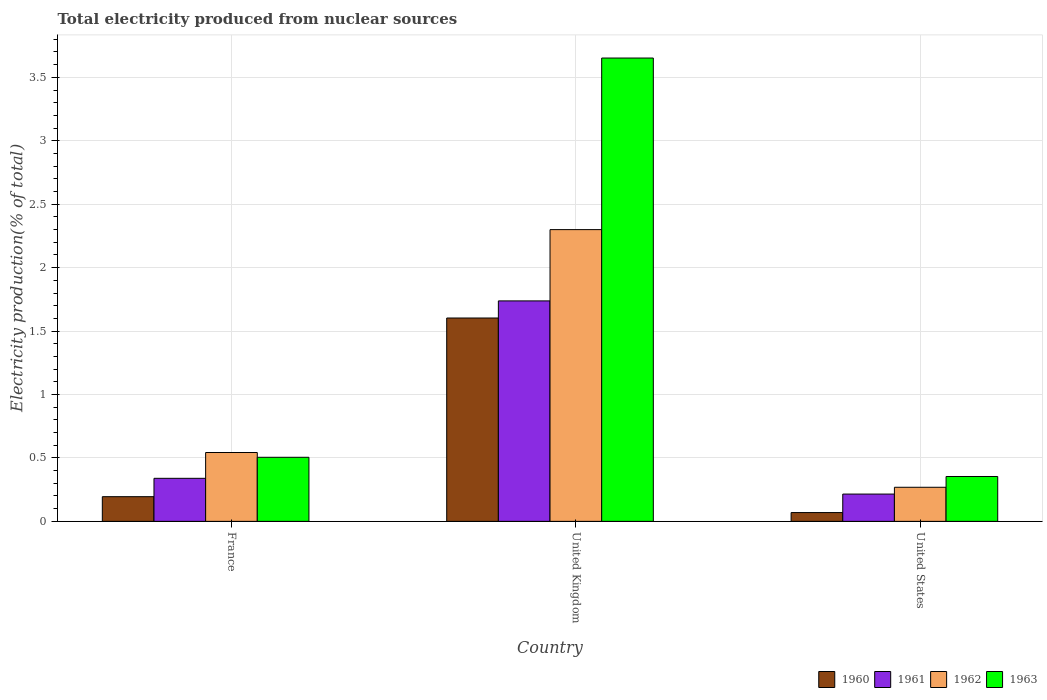Are the number of bars on each tick of the X-axis equal?
Your response must be concise. Yes. What is the label of the 2nd group of bars from the left?
Your answer should be very brief. United Kingdom. In how many cases, is the number of bars for a given country not equal to the number of legend labels?
Provide a succinct answer. 0. What is the total electricity produced in 1960 in United Kingdom?
Your answer should be very brief. 1.6. Across all countries, what is the maximum total electricity produced in 1960?
Provide a short and direct response. 1.6. Across all countries, what is the minimum total electricity produced in 1961?
Offer a terse response. 0.22. In which country was the total electricity produced in 1962 maximum?
Offer a terse response. United Kingdom. What is the total total electricity produced in 1961 in the graph?
Your answer should be compact. 2.29. What is the difference between the total electricity produced in 1960 in France and that in United States?
Provide a succinct answer. 0.13. What is the difference between the total electricity produced in 1962 in United States and the total electricity produced in 1960 in United Kingdom?
Offer a terse response. -1.33. What is the average total electricity produced in 1963 per country?
Offer a terse response. 1.5. What is the difference between the total electricity produced of/in 1962 and total electricity produced of/in 1961 in France?
Your answer should be very brief. 0.2. What is the ratio of the total electricity produced in 1961 in France to that in United Kingdom?
Ensure brevity in your answer.  0.2. Is the difference between the total electricity produced in 1962 in France and United States greater than the difference between the total electricity produced in 1961 in France and United States?
Make the answer very short. Yes. What is the difference between the highest and the second highest total electricity produced in 1962?
Keep it short and to the point. 0.27. What is the difference between the highest and the lowest total electricity produced in 1961?
Keep it short and to the point. 1.52. In how many countries, is the total electricity produced in 1963 greater than the average total electricity produced in 1963 taken over all countries?
Keep it short and to the point. 1. Is it the case that in every country, the sum of the total electricity produced in 1961 and total electricity produced in 1962 is greater than the sum of total electricity produced in 1963 and total electricity produced in 1960?
Make the answer very short. No. What does the 4th bar from the left in France represents?
Ensure brevity in your answer.  1963. Is it the case that in every country, the sum of the total electricity produced in 1961 and total electricity produced in 1962 is greater than the total electricity produced in 1960?
Keep it short and to the point. Yes. How many bars are there?
Your answer should be very brief. 12. How many countries are there in the graph?
Your answer should be very brief. 3. Are the values on the major ticks of Y-axis written in scientific E-notation?
Ensure brevity in your answer.  No. Does the graph contain any zero values?
Your response must be concise. No. How many legend labels are there?
Keep it short and to the point. 4. What is the title of the graph?
Keep it short and to the point. Total electricity produced from nuclear sources. Does "1974" appear as one of the legend labels in the graph?
Provide a succinct answer. No. What is the label or title of the X-axis?
Offer a very short reply. Country. What is the Electricity production(% of total) of 1960 in France?
Give a very brief answer. 0.19. What is the Electricity production(% of total) of 1961 in France?
Ensure brevity in your answer.  0.34. What is the Electricity production(% of total) of 1962 in France?
Your response must be concise. 0.54. What is the Electricity production(% of total) of 1963 in France?
Offer a very short reply. 0.51. What is the Electricity production(% of total) of 1960 in United Kingdom?
Your response must be concise. 1.6. What is the Electricity production(% of total) in 1961 in United Kingdom?
Offer a very short reply. 1.74. What is the Electricity production(% of total) in 1962 in United Kingdom?
Offer a very short reply. 2.3. What is the Electricity production(% of total) of 1963 in United Kingdom?
Your response must be concise. 3.65. What is the Electricity production(% of total) of 1960 in United States?
Keep it short and to the point. 0.07. What is the Electricity production(% of total) of 1961 in United States?
Offer a very short reply. 0.22. What is the Electricity production(% of total) in 1962 in United States?
Your answer should be very brief. 0.27. What is the Electricity production(% of total) in 1963 in United States?
Ensure brevity in your answer.  0.35. Across all countries, what is the maximum Electricity production(% of total) of 1960?
Give a very brief answer. 1.6. Across all countries, what is the maximum Electricity production(% of total) of 1961?
Keep it short and to the point. 1.74. Across all countries, what is the maximum Electricity production(% of total) in 1962?
Make the answer very short. 2.3. Across all countries, what is the maximum Electricity production(% of total) in 1963?
Ensure brevity in your answer.  3.65. Across all countries, what is the minimum Electricity production(% of total) of 1960?
Give a very brief answer. 0.07. Across all countries, what is the minimum Electricity production(% of total) of 1961?
Give a very brief answer. 0.22. Across all countries, what is the minimum Electricity production(% of total) of 1962?
Your answer should be compact. 0.27. Across all countries, what is the minimum Electricity production(% of total) in 1963?
Make the answer very short. 0.35. What is the total Electricity production(% of total) of 1960 in the graph?
Your response must be concise. 1.87. What is the total Electricity production(% of total) in 1961 in the graph?
Your response must be concise. 2.29. What is the total Electricity production(% of total) of 1962 in the graph?
Provide a succinct answer. 3.11. What is the total Electricity production(% of total) in 1963 in the graph?
Provide a succinct answer. 4.51. What is the difference between the Electricity production(% of total) in 1960 in France and that in United Kingdom?
Provide a succinct answer. -1.41. What is the difference between the Electricity production(% of total) in 1961 in France and that in United Kingdom?
Provide a short and direct response. -1.4. What is the difference between the Electricity production(% of total) of 1962 in France and that in United Kingdom?
Give a very brief answer. -1.76. What is the difference between the Electricity production(% of total) of 1963 in France and that in United Kingdom?
Your answer should be compact. -3.15. What is the difference between the Electricity production(% of total) in 1960 in France and that in United States?
Make the answer very short. 0.13. What is the difference between the Electricity production(% of total) in 1961 in France and that in United States?
Keep it short and to the point. 0.12. What is the difference between the Electricity production(% of total) in 1962 in France and that in United States?
Give a very brief answer. 0.27. What is the difference between the Electricity production(% of total) in 1963 in France and that in United States?
Make the answer very short. 0.15. What is the difference between the Electricity production(% of total) of 1960 in United Kingdom and that in United States?
Provide a succinct answer. 1.53. What is the difference between the Electricity production(% of total) of 1961 in United Kingdom and that in United States?
Provide a short and direct response. 1.52. What is the difference between the Electricity production(% of total) in 1962 in United Kingdom and that in United States?
Offer a terse response. 2.03. What is the difference between the Electricity production(% of total) of 1963 in United Kingdom and that in United States?
Offer a very short reply. 3.3. What is the difference between the Electricity production(% of total) of 1960 in France and the Electricity production(% of total) of 1961 in United Kingdom?
Make the answer very short. -1.54. What is the difference between the Electricity production(% of total) of 1960 in France and the Electricity production(% of total) of 1962 in United Kingdom?
Offer a very short reply. -2.11. What is the difference between the Electricity production(% of total) of 1960 in France and the Electricity production(% of total) of 1963 in United Kingdom?
Your answer should be very brief. -3.46. What is the difference between the Electricity production(% of total) in 1961 in France and the Electricity production(% of total) in 1962 in United Kingdom?
Ensure brevity in your answer.  -1.96. What is the difference between the Electricity production(% of total) in 1961 in France and the Electricity production(% of total) in 1963 in United Kingdom?
Make the answer very short. -3.31. What is the difference between the Electricity production(% of total) in 1962 in France and the Electricity production(% of total) in 1963 in United Kingdom?
Keep it short and to the point. -3.11. What is the difference between the Electricity production(% of total) of 1960 in France and the Electricity production(% of total) of 1961 in United States?
Make the answer very short. -0.02. What is the difference between the Electricity production(% of total) of 1960 in France and the Electricity production(% of total) of 1962 in United States?
Give a very brief answer. -0.07. What is the difference between the Electricity production(% of total) of 1960 in France and the Electricity production(% of total) of 1963 in United States?
Offer a very short reply. -0.16. What is the difference between the Electricity production(% of total) in 1961 in France and the Electricity production(% of total) in 1962 in United States?
Offer a terse response. 0.07. What is the difference between the Electricity production(% of total) in 1961 in France and the Electricity production(% of total) in 1963 in United States?
Ensure brevity in your answer.  -0.01. What is the difference between the Electricity production(% of total) in 1962 in France and the Electricity production(% of total) in 1963 in United States?
Keep it short and to the point. 0.19. What is the difference between the Electricity production(% of total) of 1960 in United Kingdom and the Electricity production(% of total) of 1961 in United States?
Make the answer very short. 1.39. What is the difference between the Electricity production(% of total) of 1960 in United Kingdom and the Electricity production(% of total) of 1962 in United States?
Make the answer very short. 1.33. What is the difference between the Electricity production(% of total) in 1960 in United Kingdom and the Electricity production(% of total) in 1963 in United States?
Offer a very short reply. 1.25. What is the difference between the Electricity production(% of total) of 1961 in United Kingdom and the Electricity production(% of total) of 1962 in United States?
Your answer should be very brief. 1.47. What is the difference between the Electricity production(% of total) of 1961 in United Kingdom and the Electricity production(% of total) of 1963 in United States?
Provide a succinct answer. 1.38. What is the difference between the Electricity production(% of total) in 1962 in United Kingdom and the Electricity production(% of total) in 1963 in United States?
Offer a terse response. 1.95. What is the average Electricity production(% of total) of 1960 per country?
Make the answer very short. 0.62. What is the average Electricity production(% of total) of 1961 per country?
Offer a terse response. 0.76. What is the average Electricity production(% of total) in 1962 per country?
Offer a terse response. 1.04. What is the average Electricity production(% of total) of 1963 per country?
Offer a very short reply. 1.5. What is the difference between the Electricity production(% of total) in 1960 and Electricity production(% of total) in 1961 in France?
Give a very brief answer. -0.14. What is the difference between the Electricity production(% of total) of 1960 and Electricity production(% of total) of 1962 in France?
Provide a short and direct response. -0.35. What is the difference between the Electricity production(% of total) of 1960 and Electricity production(% of total) of 1963 in France?
Make the answer very short. -0.31. What is the difference between the Electricity production(% of total) in 1961 and Electricity production(% of total) in 1962 in France?
Provide a short and direct response. -0.2. What is the difference between the Electricity production(% of total) in 1961 and Electricity production(% of total) in 1963 in France?
Your response must be concise. -0.17. What is the difference between the Electricity production(% of total) in 1962 and Electricity production(% of total) in 1963 in France?
Keep it short and to the point. 0.04. What is the difference between the Electricity production(% of total) in 1960 and Electricity production(% of total) in 1961 in United Kingdom?
Ensure brevity in your answer.  -0.13. What is the difference between the Electricity production(% of total) of 1960 and Electricity production(% of total) of 1962 in United Kingdom?
Offer a very short reply. -0.7. What is the difference between the Electricity production(% of total) of 1960 and Electricity production(% of total) of 1963 in United Kingdom?
Provide a short and direct response. -2.05. What is the difference between the Electricity production(% of total) in 1961 and Electricity production(% of total) in 1962 in United Kingdom?
Your response must be concise. -0.56. What is the difference between the Electricity production(% of total) in 1961 and Electricity production(% of total) in 1963 in United Kingdom?
Make the answer very short. -1.91. What is the difference between the Electricity production(% of total) in 1962 and Electricity production(% of total) in 1963 in United Kingdom?
Provide a short and direct response. -1.35. What is the difference between the Electricity production(% of total) in 1960 and Electricity production(% of total) in 1961 in United States?
Make the answer very short. -0.15. What is the difference between the Electricity production(% of total) in 1960 and Electricity production(% of total) in 1962 in United States?
Provide a short and direct response. -0.2. What is the difference between the Electricity production(% of total) in 1960 and Electricity production(% of total) in 1963 in United States?
Your response must be concise. -0.28. What is the difference between the Electricity production(% of total) in 1961 and Electricity production(% of total) in 1962 in United States?
Keep it short and to the point. -0.05. What is the difference between the Electricity production(% of total) of 1961 and Electricity production(% of total) of 1963 in United States?
Provide a succinct answer. -0.14. What is the difference between the Electricity production(% of total) of 1962 and Electricity production(% of total) of 1963 in United States?
Provide a short and direct response. -0.09. What is the ratio of the Electricity production(% of total) of 1960 in France to that in United Kingdom?
Keep it short and to the point. 0.12. What is the ratio of the Electricity production(% of total) of 1961 in France to that in United Kingdom?
Your answer should be very brief. 0.2. What is the ratio of the Electricity production(% of total) of 1962 in France to that in United Kingdom?
Your answer should be compact. 0.24. What is the ratio of the Electricity production(% of total) of 1963 in France to that in United Kingdom?
Your answer should be compact. 0.14. What is the ratio of the Electricity production(% of total) in 1960 in France to that in United States?
Provide a succinct answer. 2.81. What is the ratio of the Electricity production(% of total) of 1961 in France to that in United States?
Provide a succinct answer. 1.58. What is the ratio of the Electricity production(% of total) in 1962 in France to that in United States?
Offer a very short reply. 2.02. What is the ratio of the Electricity production(% of total) of 1963 in France to that in United States?
Keep it short and to the point. 1.43. What is the ratio of the Electricity production(% of total) of 1960 in United Kingdom to that in United States?
Offer a terse response. 23.14. What is the ratio of the Electricity production(% of total) in 1961 in United Kingdom to that in United States?
Your response must be concise. 8.08. What is the ratio of the Electricity production(% of total) in 1962 in United Kingdom to that in United States?
Your response must be concise. 8.56. What is the ratio of the Electricity production(% of total) in 1963 in United Kingdom to that in United States?
Provide a succinct answer. 10.32. What is the difference between the highest and the second highest Electricity production(% of total) in 1960?
Give a very brief answer. 1.41. What is the difference between the highest and the second highest Electricity production(% of total) of 1961?
Your response must be concise. 1.4. What is the difference between the highest and the second highest Electricity production(% of total) in 1962?
Give a very brief answer. 1.76. What is the difference between the highest and the second highest Electricity production(% of total) in 1963?
Ensure brevity in your answer.  3.15. What is the difference between the highest and the lowest Electricity production(% of total) of 1960?
Your answer should be very brief. 1.53. What is the difference between the highest and the lowest Electricity production(% of total) in 1961?
Offer a very short reply. 1.52. What is the difference between the highest and the lowest Electricity production(% of total) in 1962?
Make the answer very short. 2.03. What is the difference between the highest and the lowest Electricity production(% of total) of 1963?
Your answer should be very brief. 3.3. 